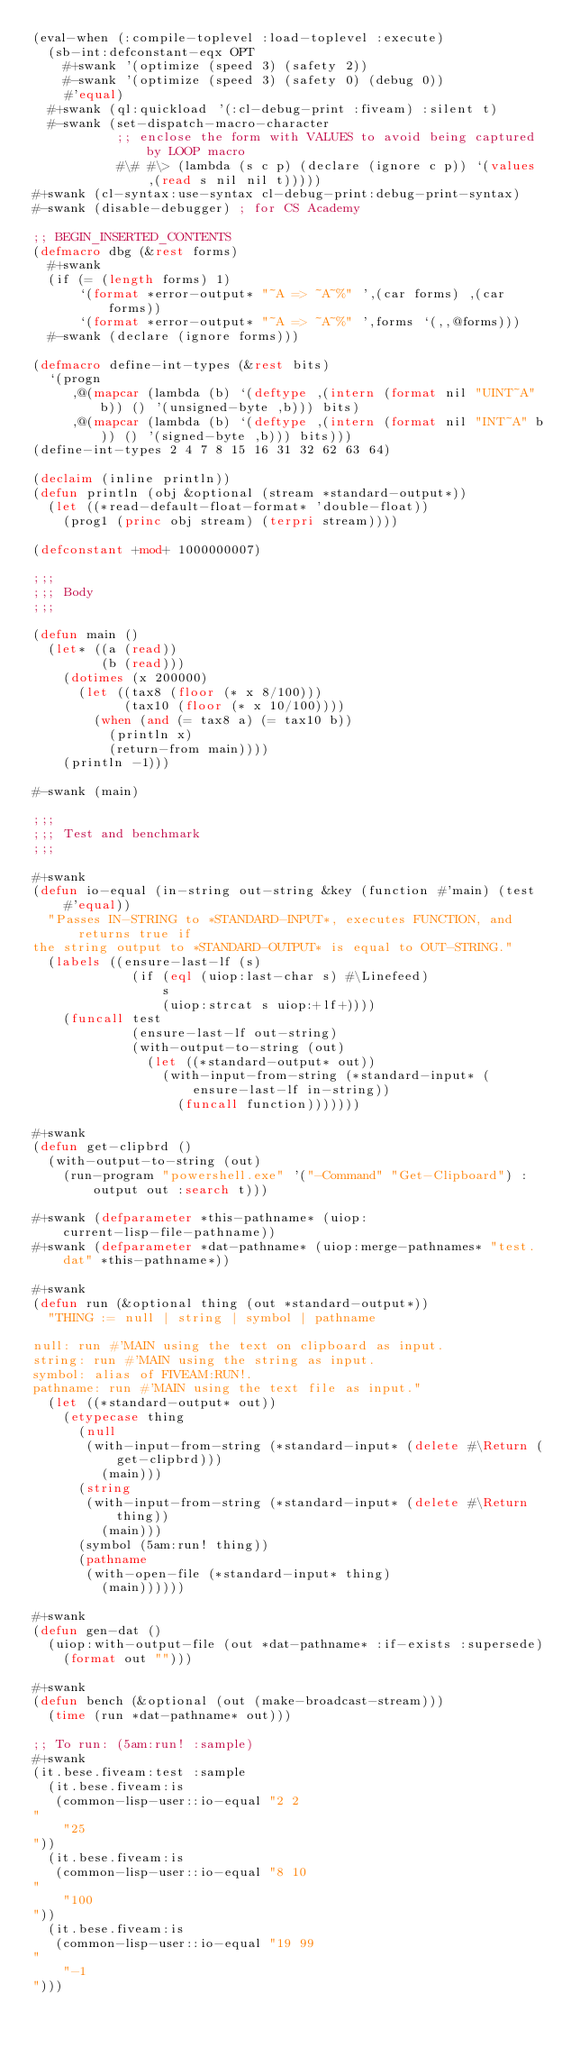<code> <loc_0><loc_0><loc_500><loc_500><_Lisp_>(eval-when (:compile-toplevel :load-toplevel :execute)
  (sb-int:defconstant-eqx OPT
    #+swank '(optimize (speed 3) (safety 2))
    #-swank '(optimize (speed 3) (safety 0) (debug 0))
    #'equal)
  #+swank (ql:quickload '(:cl-debug-print :fiveam) :silent t)
  #-swank (set-dispatch-macro-character
           ;; enclose the form with VALUES to avoid being captured by LOOP macro
           #\# #\> (lambda (s c p) (declare (ignore c p)) `(values ,(read s nil nil t)))))
#+swank (cl-syntax:use-syntax cl-debug-print:debug-print-syntax)
#-swank (disable-debugger) ; for CS Academy

;; BEGIN_INSERTED_CONTENTS
(defmacro dbg (&rest forms)
  #+swank
  (if (= (length forms) 1)
      `(format *error-output* "~A => ~A~%" ',(car forms) ,(car forms))
      `(format *error-output* "~A => ~A~%" ',forms `(,,@forms)))
  #-swank (declare (ignore forms)))

(defmacro define-int-types (&rest bits)
  `(progn
     ,@(mapcar (lambda (b) `(deftype ,(intern (format nil "UINT~A" b)) () '(unsigned-byte ,b))) bits)
     ,@(mapcar (lambda (b) `(deftype ,(intern (format nil "INT~A" b)) () '(signed-byte ,b))) bits)))
(define-int-types 2 4 7 8 15 16 31 32 62 63 64)

(declaim (inline println))
(defun println (obj &optional (stream *standard-output*))
  (let ((*read-default-float-format* 'double-float))
    (prog1 (princ obj stream) (terpri stream))))

(defconstant +mod+ 1000000007)

;;;
;;; Body
;;;

(defun main ()
  (let* ((a (read))
         (b (read)))
    (dotimes (x 200000)
      (let ((tax8 (floor (* x 8/100)))
            (tax10 (floor (* x 10/100))))
        (when (and (= tax8 a) (= tax10 b))
          (println x)
          (return-from main))))
    (println -1)))

#-swank (main)

;;;
;;; Test and benchmark
;;;

#+swank
(defun io-equal (in-string out-string &key (function #'main) (test #'equal))
  "Passes IN-STRING to *STANDARD-INPUT*, executes FUNCTION, and returns true if
the string output to *STANDARD-OUTPUT* is equal to OUT-STRING."
  (labels ((ensure-last-lf (s)
             (if (eql (uiop:last-char s) #\Linefeed)
                 s
                 (uiop:strcat s uiop:+lf+))))
    (funcall test
             (ensure-last-lf out-string)
             (with-output-to-string (out)
               (let ((*standard-output* out))
                 (with-input-from-string (*standard-input* (ensure-last-lf in-string))
                   (funcall function)))))))

#+swank
(defun get-clipbrd ()
  (with-output-to-string (out)
    (run-program "powershell.exe" '("-Command" "Get-Clipboard") :output out :search t)))

#+swank (defparameter *this-pathname* (uiop:current-lisp-file-pathname))
#+swank (defparameter *dat-pathname* (uiop:merge-pathnames* "test.dat" *this-pathname*))

#+swank
(defun run (&optional thing (out *standard-output*))
  "THING := null | string | symbol | pathname

null: run #'MAIN using the text on clipboard as input.
string: run #'MAIN using the string as input.
symbol: alias of FIVEAM:RUN!.
pathname: run #'MAIN using the text file as input."
  (let ((*standard-output* out))
    (etypecase thing
      (null
       (with-input-from-string (*standard-input* (delete #\Return (get-clipbrd)))
         (main)))
      (string
       (with-input-from-string (*standard-input* (delete #\Return thing))
         (main)))
      (symbol (5am:run! thing))
      (pathname
       (with-open-file (*standard-input* thing)
         (main))))))

#+swank
(defun gen-dat ()
  (uiop:with-output-file (out *dat-pathname* :if-exists :supersede)
    (format out "")))

#+swank
(defun bench (&optional (out (make-broadcast-stream)))
  (time (run *dat-pathname* out)))

;; To run: (5am:run! :sample)
#+swank
(it.bese.fiveam:test :sample
  (it.bese.fiveam:is
   (common-lisp-user::io-equal "2 2
"
    "25
"))
  (it.bese.fiveam:is
   (common-lisp-user::io-equal "8 10
"
    "100
"))
  (it.bese.fiveam:is
   (common-lisp-user::io-equal "19 99
"
    "-1
")))
</code> 